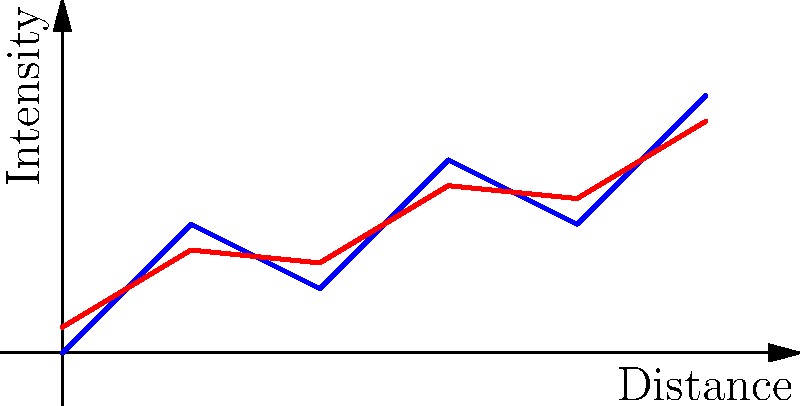In the graph above, two satellite imagery signals are shown: one before atmospheric distortion (blue) and one after (red). Calculate the average percentage decrease in signal intensity due to atmospheric distortion. To calculate the average percentage decrease in signal intensity:

1. Identify intensity values at each distance point:
   Before: (0,0), (1,1), (2,0.5), (3,1.5), (4,1), (5,2)
   After: (0,0.2), (1,0.8), (2,0.7), (3,1.3), (4,1.2), (5,1.8)

2. Calculate the difference at each point:
   (0,0) - (0,0.2) = -0.2
   (1,1) - (1,0.8) = 0.2
   (2,0.5) - (2,0.7) = -0.2
   (3,1.5) - (3,1.3) = 0.2
   (4,1) - (4,1.2) = -0.2
   (5,2) - (5,1.8) = 0.2

3. Calculate the percentage decrease at each point:
   (-0.2 / 0) × 100 = undefined (ignore this point)
   (0.2 / 1) × 100 = 20%
   (-0.2 / 0.5) × 100 = -40%
   (0.2 / 1.5) × 100 ≈ 13.33%
   (-0.2 / 1) × 100 = -20%
   (0.2 / 2) × 100 = 10%

4. Calculate the average of the percentage decreases:
   $\frac{20 + (-40) + 13.33 + (-20) + 10}{5} ≈ -3.334\%$

The negative value indicates an overall decrease in signal intensity.
Answer: 3.334% decrease 